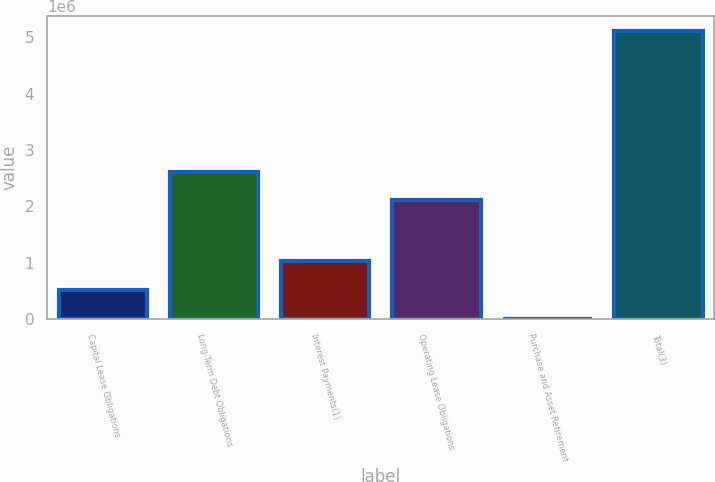<chart> <loc_0><loc_0><loc_500><loc_500><bar_chart><fcel>Capital Lease Obligations<fcel>Long-Term Debt Obligations<fcel>Interest Payments(1)<fcel>Operating Lease Obligations<fcel>Purchase and Asset Retirement<fcel>Total(3)<nl><fcel>520132<fcel>2.61633e+06<fcel>1.03092e+06<fcel>2.10555e+06<fcel>9349<fcel>5.11718e+06<nl></chart> 